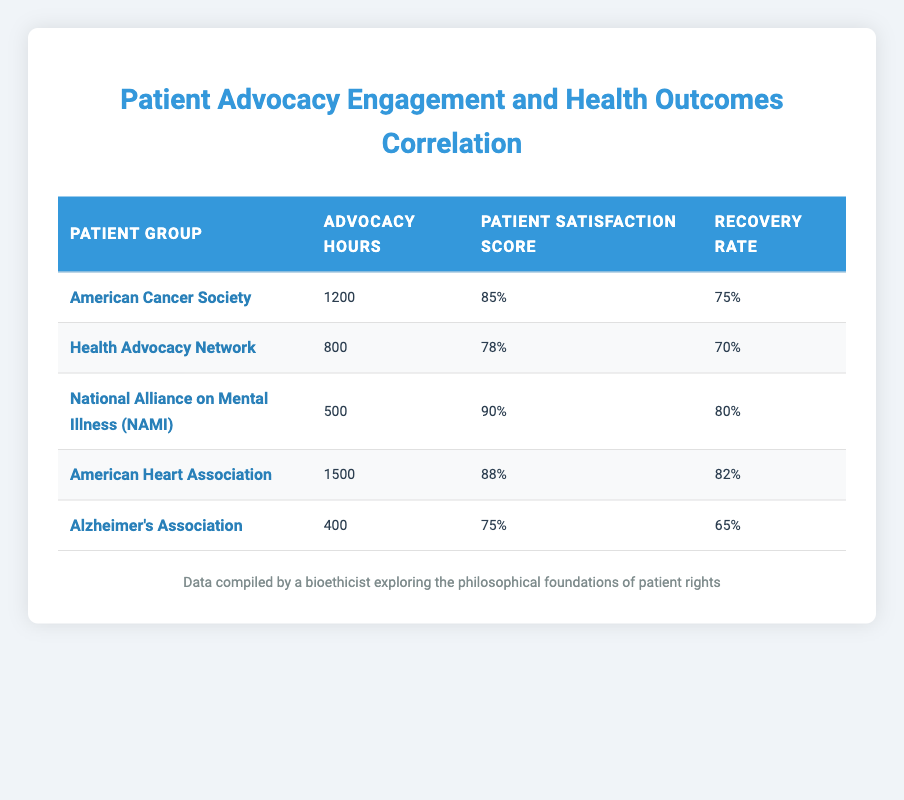What is the patient satisfaction score for the Health Advocacy Network? The table provides a direct reference to the patient satisfaction score for the Health Advocacy Network, which is listed as 78%.
Answer: 78% Which patient group has the highest recovery rate? By comparing the recovery rates in the table: American Cancer Society (75%), Health Advocacy Network (70%), NAMI (80%), American Heart Association (82%), and Alzheimer’s Association (65%). The American Heart Association has the highest recovery rate at 82%.
Answer: American Heart Association What is the average advocacy hours for the patient groups listed? First, we sum the advocacy hours: 1200 + 800 + 500 + 1500 + 400 = 3400 hours. Then, we divide by the number of groups (5): 3400 / 5 = 680 hours.
Answer: 680 Is the patient satisfaction score for the American Cancer Society greater than 80%? The patient satisfaction score for the American Cancer Society is 85%, which is indeed greater than 80%.
Answer: Yes How does the recovery rate of NAMI compare to that of Alzheimer’s Association? The recovery rate for NAMI is 80% and for Alzheimer’s Association, it is 65%. Therefore, NAMI has a higher recovery rate by 15%.
Answer: NAMI has a higher recovery rate by 15% 